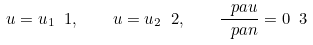Convert formula to latex. <formula><loc_0><loc_0><loc_500><loc_500>u = u _ { 1 } \ 1 , \quad u = u _ { 2 } \ 2 , \quad \frac { \ p a u } { \ p a n } = 0 \ 3</formula> 